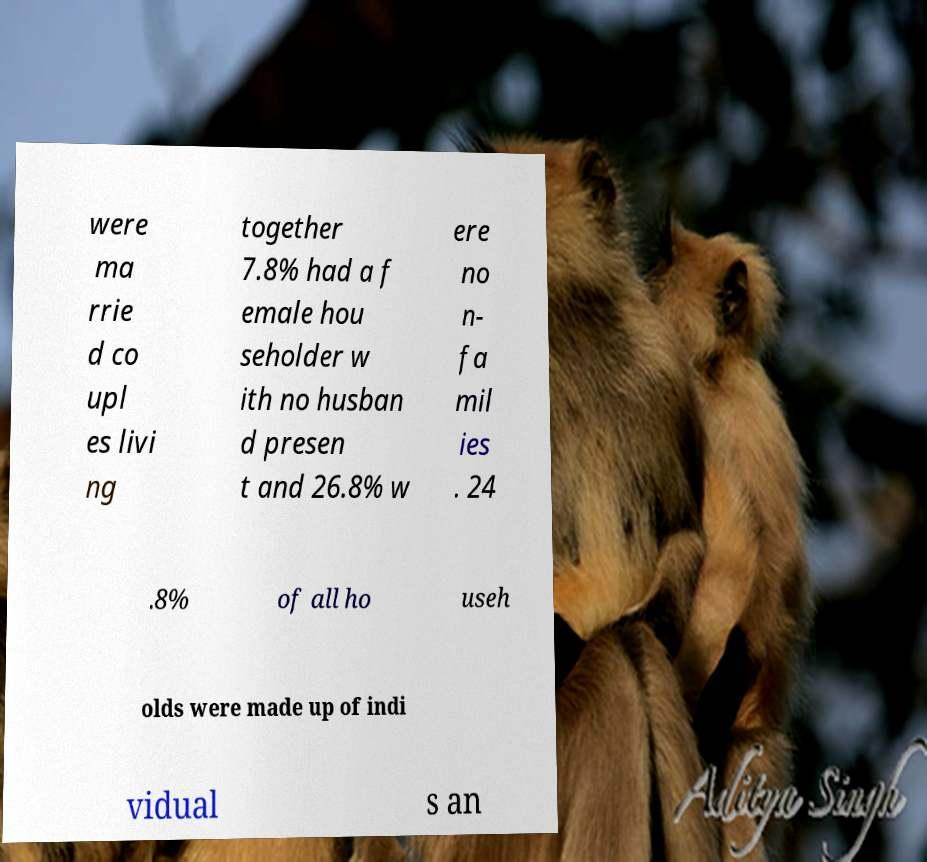What messages or text are displayed in this image? I need them in a readable, typed format. were ma rrie d co upl es livi ng together 7.8% had a f emale hou seholder w ith no husban d presen t and 26.8% w ere no n- fa mil ies . 24 .8% of all ho useh olds were made up of indi vidual s an 